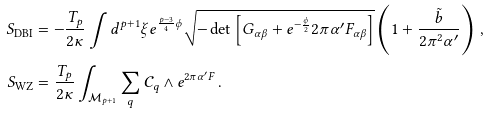<formula> <loc_0><loc_0><loc_500><loc_500>S _ { \text {DBI} } & = - \frac { T _ { p } } { 2 \kappa } \int d ^ { p + 1 } \xi e ^ { \frac { p - 3 } { 4 } \phi } \sqrt { - \det \left [ G _ { \alpha \beta } + e ^ { - \frac { \phi } { 2 } } 2 \pi \alpha ^ { \prime } F _ { \alpha \beta } \right ] } \left ( 1 + \frac { \tilde { b } } { 2 \pi ^ { 2 } \alpha ^ { \prime } } \right ) \, , \\ S _ { \text {WZ} } & = \frac { T _ { p } } { 2 \kappa } \int _ { \mathcal { M } _ { p + 1 } } \sum _ { q } \mathcal { C } _ { q } \wedge e ^ { 2 \pi \alpha ^ { \prime } F } \, .</formula> 